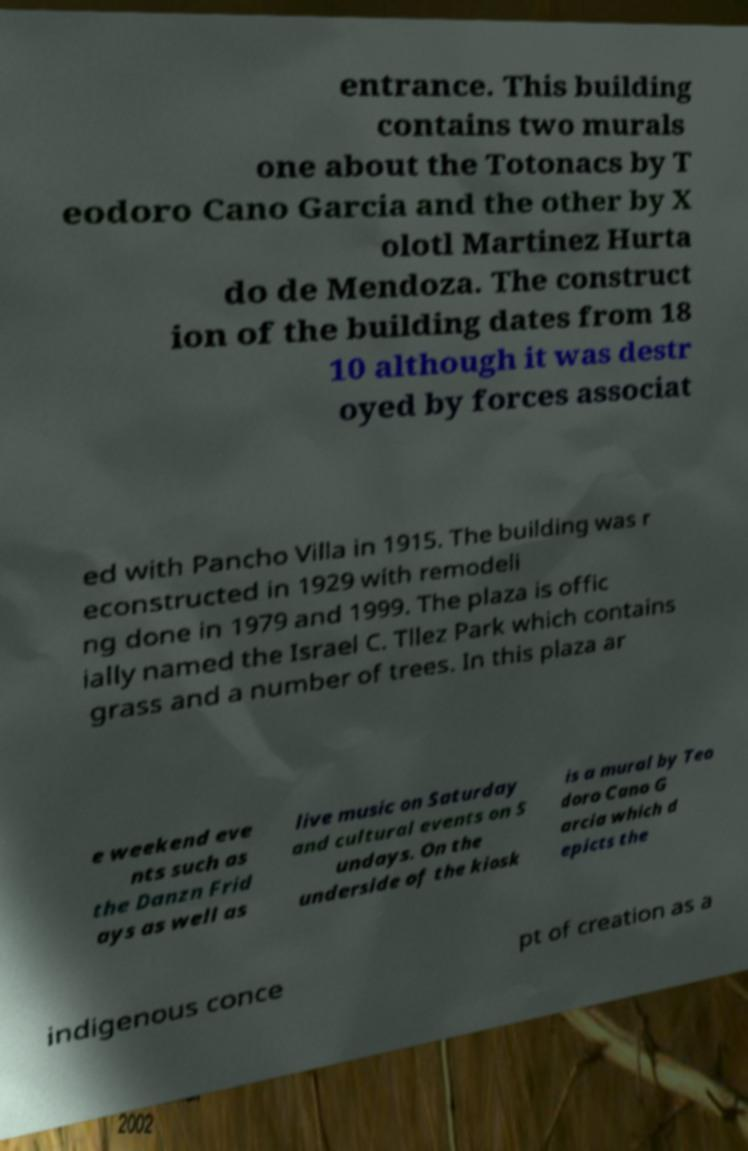Can you read and provide the text displayed in the image?This photo seems to have some interesting text. Can you extract and type it out for me? entrance. This building contains two murals one about the Totonacs by T eodoro Cano Garcia and the other by X olotl Martinez Hurta do de Mendoza. The construct ion of the building dates from 18 10 although it was destr oyed by forces associat ed with Pancho Villa in 1915. The building was r econstructed in 1929 with remodeli ng done in 1979 and 1999. The plaza is offic ially named the Israel C. Tllez Park which contains grass and a number of trees. In this plaza ar e weekend eve nts such as the Danzn Frid ays as well as live music on Saturday and cultural events on S undays. On the underside of the kiosk is a mural by Teo doro Cano G arcia which d epicts the indigenous conce pt of creation as a 